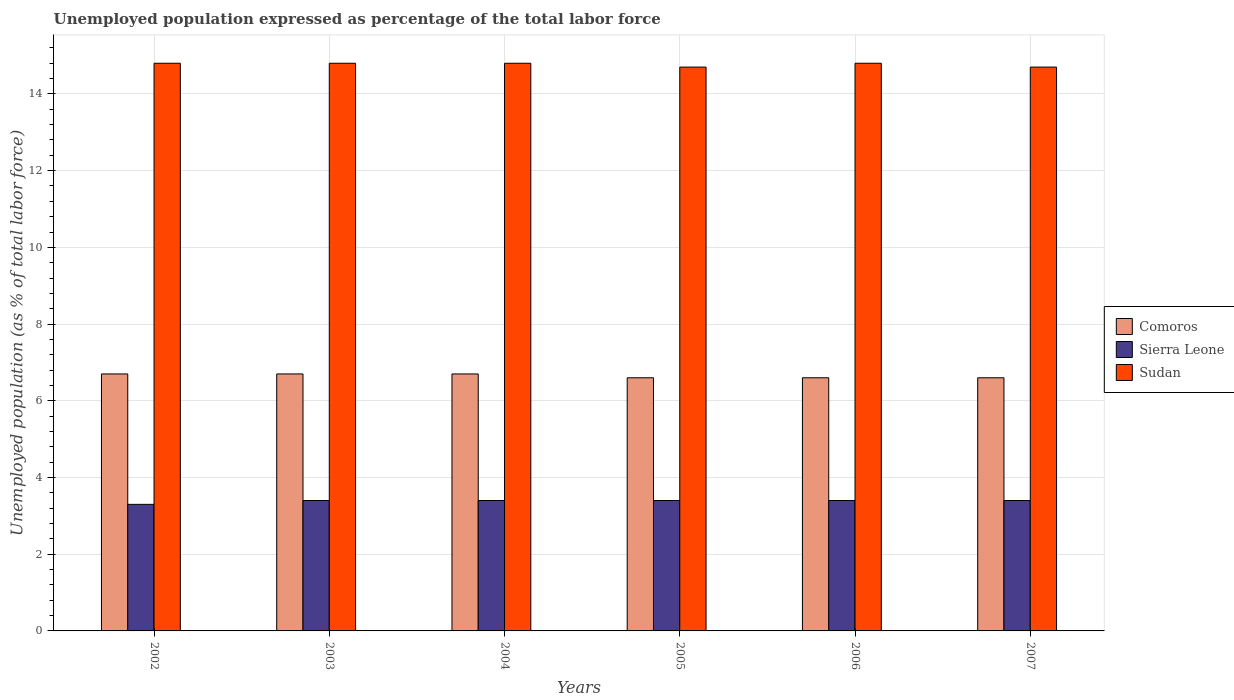How many groups of bars are there?
Ensure brevity in your answer.  6. How many bars are there on the 3rd tick from the left?
Ensure brevity in your answer.  3. How many bars are there on the 5th tick from the right?
Your answer should be compact. 3. In how many cases, is the number of bars for a given year not equal to the number of legend labels?
Ensure brevity in your answer.  0. What is the unemployment in in Comoros in 2002?
Your answer should be very brief. 6.7. Across all years, what is the maximum unemployment in in Sierra Leone?
Offer a terse response. 3.4. Across all years, what is the minimum unemployment in in Sierra Leone?
Your answer should be very brief. 3.3. In which year was the unemployment in in Sierra Leone maximum?
Provide a succinct answer. 2003. What is the total unemployment in in Comoros in the graph?
Provide a succinct answer. 39.9. What is the difference between the unemployment in in Comoros in 2007 and the unemployment in in Sudan in 2003?
Make the answer very short. -8.2. What is the average unemployment in in Sudan per year?
Offer a terse response. 14.77. In the year 2007, what is the difference between the unemployment in in Sierra Leone and unemployment in in Sudan?
Your answer should be compact. -11.3. In how many years, is the unemployment in in Comoros greater than 4.4 %?
Keep it short and to the point. 6. What is the ratio of the unemployment in in Comoros in 2003 to that in 2006?
Keep it short and to the point. 1.02. Is the difference between the unemployment in in Sierra Leone in 2002 and 2006 greater than the difference between the unemployment in in Sudan in 2002 and 2006?
Keep it short and to the point. No. What is the difference between the highest and the second highest unemployment in in Sudan?
Offer a terse response. 0. What is the difference between the highest and the lowest unemployment in in Comoros?
Your response must be concise. 0.1. What does the 3rd bar from the left in 2003 represents?
Your answer should be very brief. Sudan. What does the 3rd bar from the right in 2003 represents?
Offer a very short reply. Comoros. Is it the case that in every year, the sum of the unemployment in in Sudan and unemployment in in Sierra Leone is greater than the unemployment in in Comoros?
Keep it short and to the point. Yes. Are all the bars in the graph horizontal?
Your response must be concise. No. How many years are there in the graph?
Your answer should be very brief. 6. Does the graph contain any zero values?
Provide a short and direct response. No. How are the legend labels stacked?
Give a very brief answer. Vertical. What is the title of the graph?
Offer a terse response. Unemployed population expressed as percentage of the total labor force. What is the label or title of the Y-axis?
Your response must be concise. Unemployed population (as % of total labor force). What is the Unemployed population (as % of total labor force) of Comoros in 2002?
Your answer should be very brief. 6.7. What is the Unemployed population (as % of total labor force) of Sierra Leone in 2002?
Give a very brief answer. 3.3. What is the Unemployed population (as % of total labor force) in Sudan in 2002?
Keep it short and to the point. 14.8. What is the Unemployed population (as % of total labor force) in Comoros in 2003?
Provide a short and direct response. 6.7. What is the Unemployed population (as % of total labor force) of Sierra Leone in 2003?
Provide a short and direct response. 3.4. What is the Unemployed population (as % of total labor force) of Sudan in 2003?
Give a very brief answer. 14.8. What is the Unemployed population (as % of total labor force) of Comoros in 2004?
Offer a terse response. 6.7. What is the Unemployed population (as % of total labor force) of Sierra Leone in 2004?
Your answer should be very brief. 3.4. What is the Unemployed population (as % of total labor force) in Sudan in 2004?
Give a very brief answer. 14.8. What is the Unemployed population (as % of total labor force) in Comoros in 2005?
Offer a terse response. 6.6. What is the Unemployed population (as % of total labor force) in Sierra Leone in 2005?
Provide a short and direct response. 3.4. What is the Unemployed population (as % of total labor force) of Sudan in 2005?
Provide a succinct answer. 14.7. What is the Unemployed population (as % of total labor force) in Comoros in 2006?
Ensure brevity in your answer.  6.6. What is the Unemployed population (as % of total labor force) of Sierra Leone in 2006?
Make the answer very short. 3.4. What is the Unemployed population (as % of total labor force) in Sudan in 2006?
Keep it short and to the point. 14.8. What is the Unemployed population (as % of total labor force) of Comoros in 2007?
Give a very brief answer. 6.6. What is the Unemployed population (as % of total labor force) of Sierra Leone in 2007?
Your answer should be very brief. 3.4. What is the Unemployed population (as % of total labor force) in Sudan in 2007?
Keep it short and to the point. 14.7. Across all years, what is the maximum Unemployed population (as % of total labor force) in Comoros?
Your response must be concise. 6.7. Across all years, what is the maximum Unemployed population (as % of total labor force) of Sierra Leone?
Provide a short and direct response. 3.4. Across all years, what is the maximum Unemployed population (as % of total labor force) of Sudan?
Your response must be concise. 14.8. Across all years, what is the minimum Unemployed population (as % of total labor force) of Comoros?
Make the answer very short. 6.6. Across all years, what is the minimum Unemployed population (as % of total labor force) in Sierra Leone?
Give a very brief answer. 3.3. Across all years, what is the minimum Unemployed population (as % of total labor force) of Sudan?
Your response must be concise. 14.7. What is the total Unemployed population (as % of total labor force) of Comoros in the graph?
Provide a succinct answer. 39.9. What is the total Unemployed population (as % of total labor force) in Sierra Leone in the graph?
Offer a very short reply. 20.3. What is the total Unemployed population (as % of total labor force) in Sudan in the graph?
Your answer should be compact. 88.6. What is the difference between the Unemployed population (as % of total labor force) of Sudan in 2002 and that in 2003?
Give a very brief answer. 0. What is the difference between the Unemployed population (as % of total labor force) in Sierra Leone in 2002 and that in 2006?
Give a very brief answer. -0.1. What is the difference between the Unemployed population (as % of total labor force) of Sudan in 2002 and that in 2006?
Provide a succinct answer. 0. What is the difference between the Unemployed population (as % of total labor force) of Comoros in 2002 and that in 2007?
Your answer should be compact. 0.1. What is the difference between the Unemployed population (as % of total labor force) of Sierra Leone in 2003 and that in 2004?
Keep it short and to the point. 0. What is the difference between the Unemployed population (as % of total labor force) in Sudan in 2003 and that in 2004?
Offer a very short reply. 0. What is the difference between the Unemployed population (as % of total labor force) in Comoros in 2003 and that in 2005?
Offer a very short reply. 0.1. What is the difference between the Unemployed population (as % of total labor force) in Sierra Leone in 2003 and that in 2005?
Your answer should be compact. 0. What is the difference between the Unemployed population (as % of total labor force) in Sudan in 2003 and that in 2007?
Ensure brevity in your answer.  0.1. What is the difference between the Unemployed population (as % of total labor force) of Sudan in 2004 and that in 2005?
Provide a succinct answer. 0.1. What is the difference between the Unemployed population (as % of total labor force) in Sudan in 2004 and that in 2006?
Offer a very short reply. 0. What is the difference between the Unemployed population (as % of total labor force) in Sierra Leone in 2004 and that in 2007?
Make the answer very short. 0. What is the difference between the Unemployed population (as % of total labor force) of Sudan in 2004 and that in 2007?
Give a very brief answer. 0.1. What is the difference between the Unemployed population (as % of total labor force) of Comoros in 2005 and that in 2006?
Make the answer very short. 0. What is the difference between the Unemployed population (as % of total labor force) in Sierra Leone in 2005 and that in 2006?
Make the answer very short. 0. What is the difference between the Unemployed population (as % of total labor force) of Sudan in 2005 and that in 2006?
Your response must be concise. -0.1. What is the difference between the Unemployed population (as % of total labor force) of Comoros in 2005 and that in 2007?
Offer a very short reply. 0. What is the difference between the Unemployed population (as % of total labor force) of Sudan in 2005 and that in 2007?
Provide a succinct answer. 0. What is the difference between the Unemployed population (as % of total labor force) in Sierra Leone in 2002 and the Unemployed population (as % of total labor force) in Sudan in 2003?
Provide a succinct answer. -11.5. What is the difference between the Unemployed population (as % of total labor force) of Comoros in 2002 and the Unemployed population (as % of total labor force) of Sierra Leone in 2004?
Your answer should be very brief. 3.3. What is the difference between the Unemployed population (as % of total labor force) in Sierra Leone in 2002 and the Unemployed population (as % of total labor force) in Sudan in 2004?
Provide a succinct answer. -11.5. What is the difference between the Unemployed population (as % of total labor force) of Comoros in 2002 and the Unemployed population (as % of total labor force) of Sudan in 2005?
Ensure brevity in your answer.  -8. What is the difference between the Unemployed population (as % of total labor force) in Comoros in 2002 and the Unemployed population (as % of total labor force) in Sudan in 2006?
Your answer should be very brief. -8.1. What is the difference between the Unemployed population (as % of total labor force) in Comoros in 2002 and the Unemployed population (as % of total labor force) in Sierra Leone in 2007?
Keep it short and to the point. 3.3. What is the difference between the Unemployed population (as % of total labor force) of Comoros in 2003 and the Unemployed population (as % of total labor force) of Sudan in 2004?
Provide a short and direct response. -8.1. What is the difference between the Unemployed population (as % of total labor force) in Comoros in 2003 and the Unemployed population (as % of total labor force) in Sierra Leone in 2005?
Provide a short and direct response. 3.3. What is the difference between the Unemployed population (as % of total labor force) of Comoros in 2003 and the Unemployed population (as % of total labor force) of Sudan in 2005?
Your response must be concise. -8. What is the difference between the Unemployed population (as % of total labor force) in Sierra Leone in 2003 and the Unemployed population (as % of total labor force) in Sudan in 2005?
Offer a terse response. -11.3. What is the difference between the Unemployed population (as % of total labor force) of Sierra Leone in 2003 and the Unemployed population (as % of total labor force) of Sudan in 2006?
Your response must be concise. -11.4. What is the difference between the Unemployed population (as % of total labor force) of Comoros in 2003 and the Unemployed population (as % of total labor force) of Sierra Leone in 2007?
Provide a short and direct response. 3.3. What is the difference between the Unemployed population (as % of total labor force) in Comoros in 2003 and the Unemployed population (as % of total labor force) in Sudan in 2007?
Ensure brevity in your answer.  -8. What is the difference between the Unemployed population (as % of total labor force) in Comoros in 2004 and the Unemployed population (as % of total labor force) in Sierra Leone in 2005?
Your response must be concise. 3.3. What is the difference between the Unemployed population (as % of total labor force) of Sierra Leone in 2004 and the Unemployed population (as % of total labor force) of Sudan in 2005?
Offer a very short reply. -11.3. What is the difference between the Unemployed population (as % of total labor force) of Sierra Leone in 2004 and the Unemployed population (as % of total labor force) of Sudan in 2006?
Offer a very short reply. -11.4. What is the difference between the Unemployed population (as % of total labor force) of Sierra Leone in 2005 and the Unemployed population (as % of total labor force) of Sudan in 2006?
Ensure brevity in your answer.  -11.4. What is the difference between the Unemployed population (as % of total labor force) in Comoros in 2005 and the Unemployed population (as % of total labor force) in Sudan in 2007?
Your answer should be compact. -8.1. What is the difference between the Unemployed population (as % of total labor force) of Comoros in 2006 and the Unemployed population (as % of total labor force) of Sierra Leone in 2007?
Your answer should be very brief. 3.2. What is the difference between the Unemployed population (as % of total labor force) of Comoros in 2006 and the Unemployed population (as % of total labor force) of Sudan in 2007?
Make the answer very short. -8.1. What is the average Unemployed population (as % of total labor force) of Comoros per year?
Offer a very short reply. 6.65. What is the average Unemployed population (as % of total labor force) in Sierra Leone per year?
Give a very brief answer. 3.38. What is the average Unemployed population (as % of total labor force) in Sudan per year?
Your answer should be compact. 14.77. In the year 2002, what is the difference between the Unemployed population (as % of total labor force) of Comoros and Unemployed population (as % of total labor force) of Sierra Leone?
Keep it short and to the point. 3.4. In the year 2002, what is the difference between the Unemployed population (as % of total labor force) in Sierra Leone and Unemployed population (as % of total labor force) in Sudan?
Offer a very short reply. -11.5. In the year 2003, what is the difference between the Unemployed population (as % of total labor force) in Comoros and Unemployed population (as % of total labor force) in Sierra Leone?
Make the answer very short. 3.3. In the year 2003, what is the difference between the Unemployed population (as % of total labor force) in Comoros and Unemployed population (as % of total labor force) in Sudan?
Your answer should be very brief. -8.1. In the year 2004, what is the difference between the Unemployed population (as % of total labor force) of Comoros and Unemployed population (as % of total labor force) of Sudan?
Keep it short and to the point. -8.1. In the year 2004, what is the difference between the Unemployed population (as % of total labor force) in Sierra Leone and Unemployed population (as % of total labor force) in Sudan?
Provide a succinct answer. -11.4. In the year 2005, what is the difference between the Unemployed population (as % of total labor force) in Comoros and Unemployed population (as % of total labor force) in Sierra Leone?
Make the answer very short. 3.2. In the year 2005, what is the difference between the Unemployed population (as % of total labor force) in Sierra Leone and Unemployed population (as % of total labor force) in Sudan?
Provide a succinct answer. -11.3. In the year 2006, what is the difference between the Unemployed population (as % of total labor force) in Comoros and Unemployed population (as % of total labor force) in Sudan?
Give a very brief answer. -8.2. In the year 2007, what is the difference between the Unemployed population (as % of total labor force) in Comoros and Unemployed population (as % of total labor force) in Sierra Leone?
Provide a short and direct response. 3.2. What is the ratio of the Unemployed population (as % of total labor force) in Comoros in 2002 to that in 2003?
Ensure brevity in your answer.  1. What is the ratio of the Unemployed population (as % of total labor force) of Sierra Leone in 2002 to that in 2003?
Give a very brief answer. 0.97. What is the ratio of the Unemployed population (as % of total labor force) in Comoros in 2002 to that in 2004?
Keep it short and to the point. 1. What is the ratio of the Unemployed population (as % of total labor force) of Sierra Leone in 2002 to that in 2004?
Give a very brief answer. 0.97. What is the ratio of the Unemployed population (as % of total labor force) of Comoros in 2002 to that in 2005?
Give a very brief answer. 1.02. What is the ratio of the Unemployed population (as % of total labor force) in Sierra Leone in 2002 to that in 2005?
Offer a terse response. 0.97. What is the ratio of the Unemployed population (as % of total labor force) in Sudan in 2002 to that in 2005?
Your answer should be compact. 1.01. What is the ratio of the Unemployed population (as % of total labor force) in Comoros in 2002 to that in 2006?
Provide a short and direct response. 1.02. What is the ratio of the Unemployed population (as % of total labor force) in Sierra Leone in 2002 to that in 2006?
Offer a terse response. 0.97. What is the ratio of the Unemployed population (as % of total labor force) in Comoros in 2002 to that in 2007?
Give a very brief answer. 1.02. What is the ratio of the Unemployed population (as % of total labor force) of Sierra Leone in 2002 to that in 2007?
Your answer should be compact. 0.97. What is the ratio of the Unemployed population (as % of total labor force) in Sudan in 2002 to that in 2007?
Give a very brief answer. 1.01. What is the ratio of the Unemployed population (as % of total labor force) in Comoros in 2003 to that in 2004?
Provide a short and direct response. 1. What is the ratio of the Unemployed population (as % of total labor force) in Comoros in 2003 to that in 2005?
Give a very brief answer. 1.02. What is the ratio of the Unemployed population (as % of total labor force) of Sudan in 2003 to that in 2005?
Offer a very short reply. 1.01. What is the ratio of the Unemployed population (as % of total labor force) in Comoros in 2003 to that in 2006?
Provide a short and direct response. 1.02. What is the ratio of the Unemployed population (as % of total labor force) of Sierra Leone in 2003 to that in 2006?
Make the answer very short. 1. What is the ratio of the Unemployed population (as % of total labor force) in Sudan in 2003 to that in 2006?
Your response must be concise. 1. What is the ratio of the Unemployed population (as % of total labor force) in Comoros in 2003 to that in 2007?
Your answer should be compact. 1.02. What is the ratio of the Unemployed population (as % of total labor force) of Sierra Leone in 2003 to that in 2007?
Keep it short and to the point. 1. What is the ratio of the Unemployed population (as % of total labor force) of Sudan in 2003 to that in 2007?
Provide a succinct answer. 1.01. What is the ratio of the Unemployed population (as % of total labor force) in Comoros in 2004 to that in 2005?
Make the answer very short. 1.02. What is the ratio of the Unemployed population (as % of total labor force) of Sudan in 2004 to that in 2005?
Provide a short and direct response. 1.01. What is the ratio of the Unemployed population (as % of total labor force) in Comoros in 2004 to that in 2006?
Give a very brief answer. 1.02. What is the ratio of the Unemployed population (as % of total labor force) in Sierra Leone in 2004 to that in 2006?
Your answer should be compact. 1. What is the ratio of the Unemployed population (as % of total labor force) of Sudan in 2004 to that in 2006?
Your answer should be very brief. 1. What is the ratio of the Unemployed population (as % of total labor force) in Comoros in 2004 to that in 2007?
Your response must be concise. 1.02. What is the ratio of the Unemployed population (as % of total labor force) in Sierra Leone in 2004 to that in 2007?
Your answer should be compact. 1. What is the ratio of the Unemployed population (as % of total labor force) in Sudan in 2004 to that in 2007?
Keep it short and to the point. 1.01. What is the ratio of the Unemployed population (as % of total labor force) of Sierra Leone in 2005 to that in 2006?
Offer a very short reply. 1. What is the ratio of the Unemployed population (as % of total labor force) in Sudan in 2005 to that in 2007?
Ensure brevity in your answer.  1. What is the ratio of the Unemployed population (as % of total labor force) of Comoros in 2006 to that in 2007?
Give a very brief answer. 1. What is the ratio of the Unemployed population (as % of total labor force) in Sudan in 2006 to that in 2007?
Your answer should be compact. 1.01. What is the difference between the highest and the second highest Unemployed population (as % of total labor force) in Comoros?
Ensure brevity in your answer.  0. What is the difference between the highest and the second highest Unemployed population (as % of total labor force) in Sudan?
Give a very brief answer. 0. What is the difference between the highest and the lowest Unemployed population (as % of total labor force) of Sierra Leone?
Provide a succinct answer. 0.1. What is the difference between the highest and the lowest Unemployed population (as % of total labor force) in Sudan?
Your answer should be compact. 0.1. 